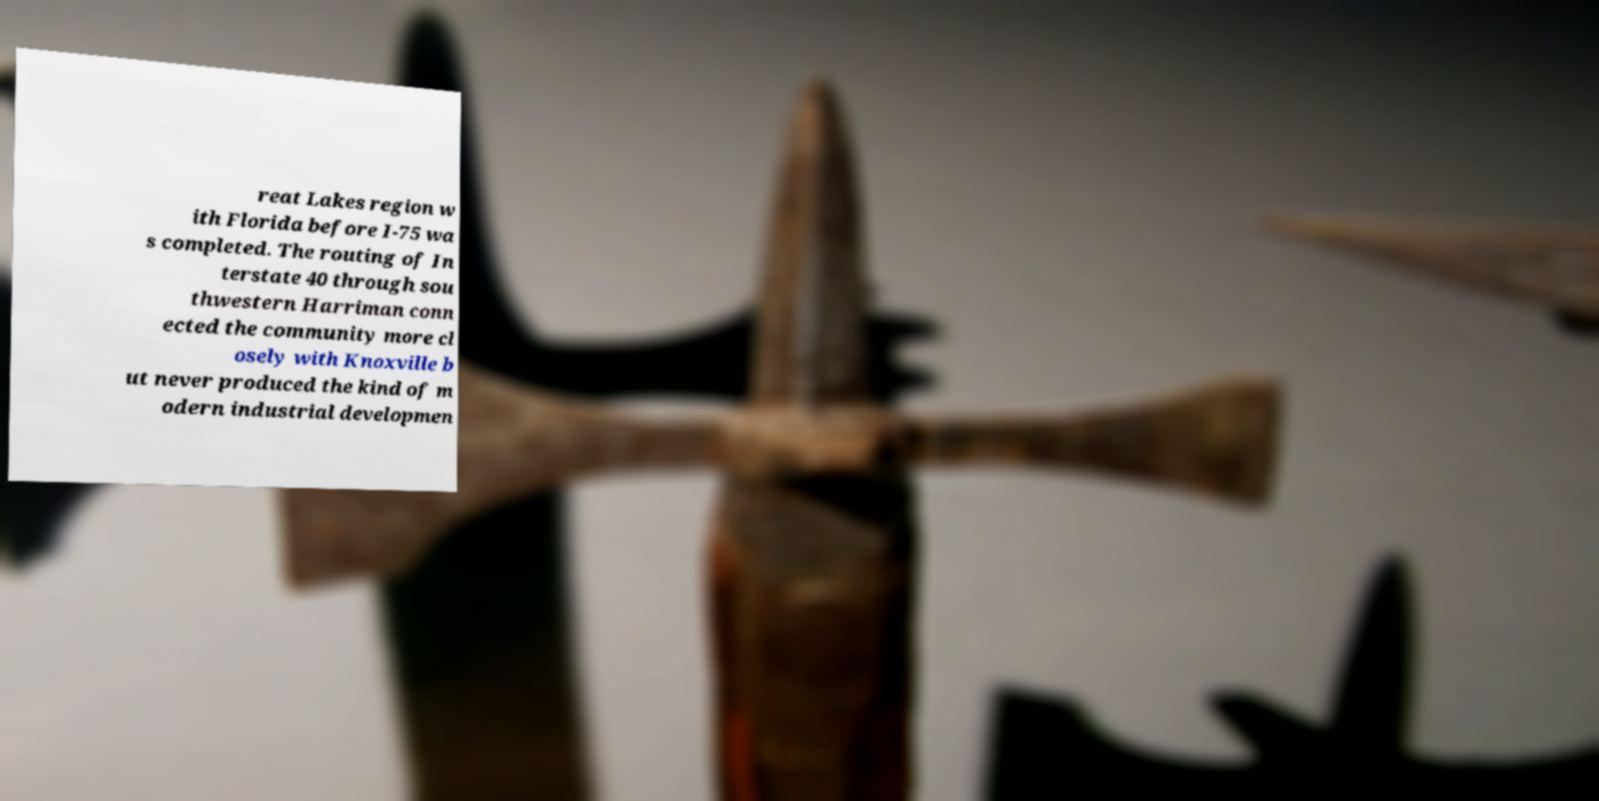Can you read and provide the text displayed in the image?This photo seems to have some interesting text. Can you extract and type it out for me? reat Lakes region w ith Florida before I-75 wa s completed. The routing of In terstate 40 through sou thwestern Harriman conn ected the community more cl osely with Knoxville b ut never produced the kind of m odern industrial developmen 